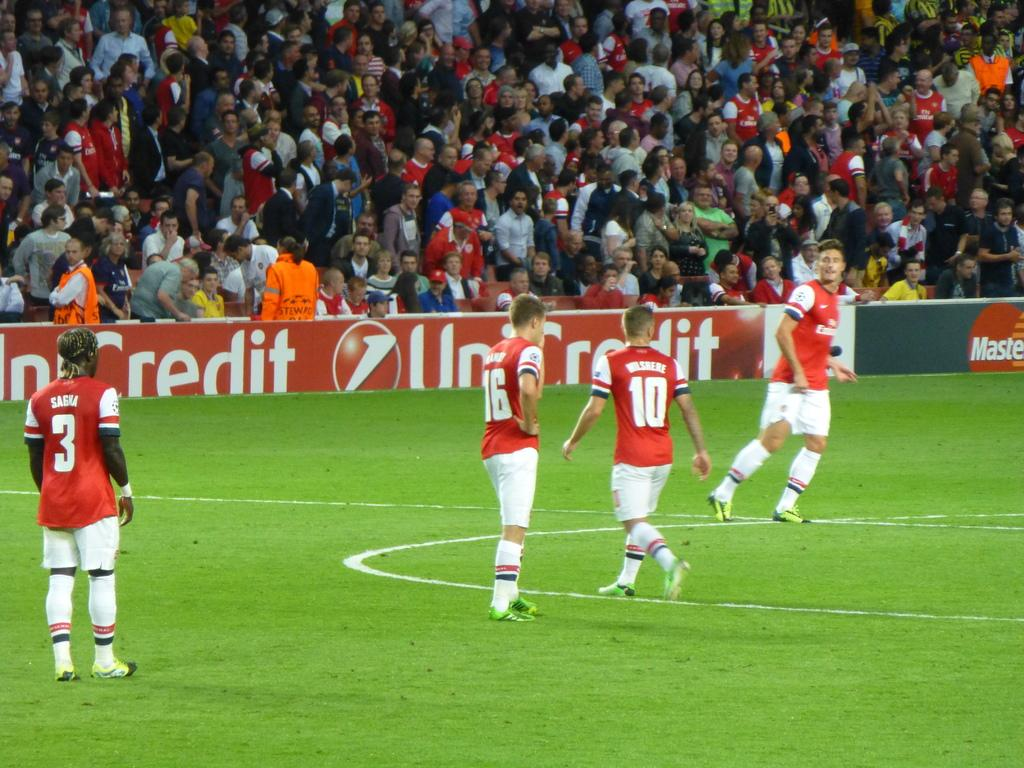<image>
Relay a brief, clear account of the picture shown. Several soccer players running down a field with one having the number 10 on his back. 